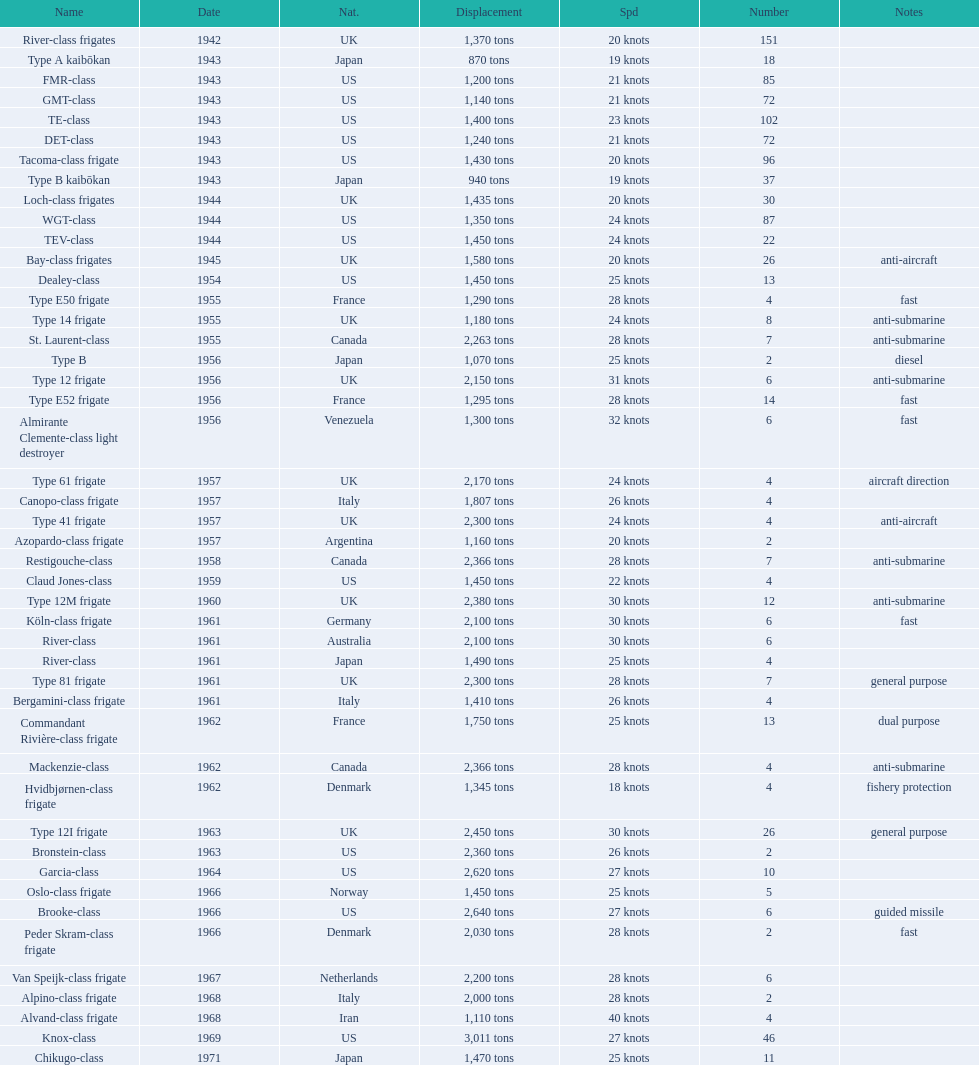What's the tonnage of displacement for type b? 940 tons. 